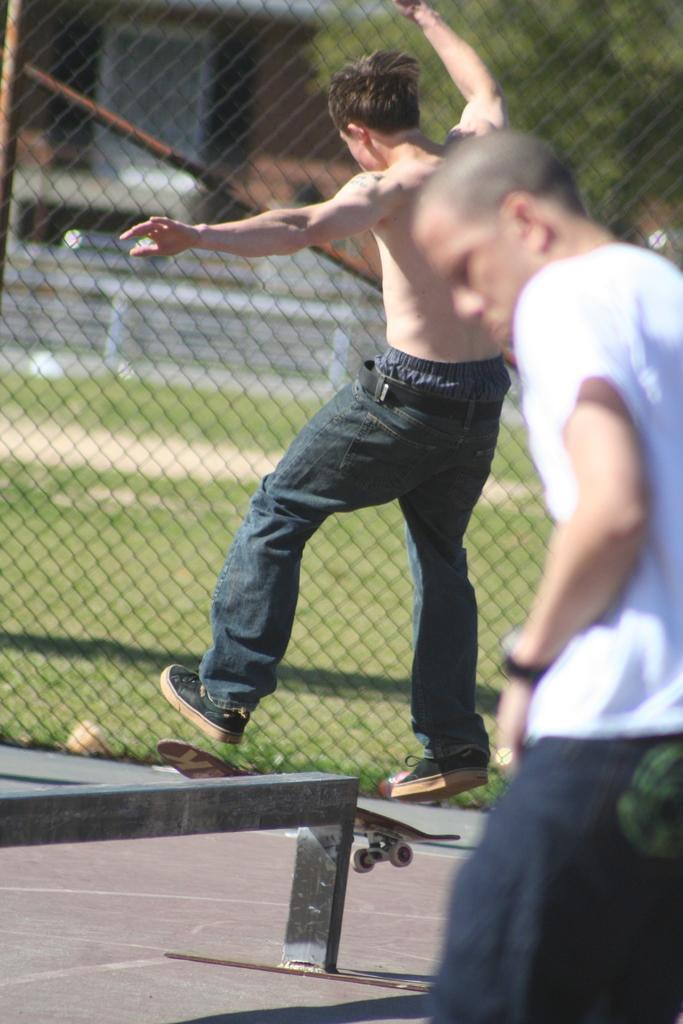What is the main subject of the image? There is a person on a skateboard in the image. What is near the skateboarder? There is a small wall near the skateboarder. Are there any other people in the image? Yes, there is a person on the right side of the image. What can be seen in the background of the image? There is a mesh wall in the background of the image. What letters can be seen on the skateboard in the image? There are no letters visible on the skateboard in the image. What is the skateboarder teaching the person on the right side of the image? There is no indication in the image that the skateboarder is teaching anything to the person on the right side. 